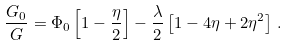<formula> <loc_0><loc_0><loc_500><loc_500>\frac { G _ { 0 } } { G } = \Phi _ { 0 } \left [ 1 - \frac { \eta } { 2 } \right ] - \frac { \lambda } { 2 } \left [ 1 - 4 \eta + 2 \eta ^ { 2 } \right ] \, .</formula> 